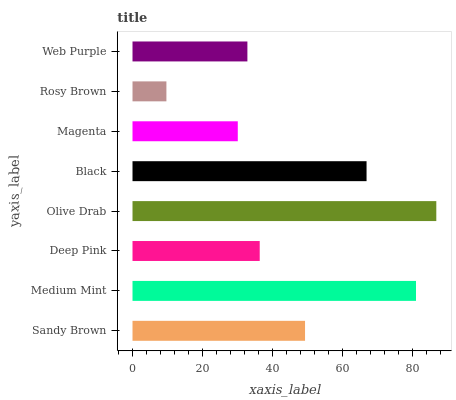Is Rosy Brown the minimum?
Answer yes or no. Yes. Is Olive Drab the maximum?
Answer yes or no. Yes. Is Medium Mint the minimum?
Answer yes or no. No. Is Medium Mint the maximum?
Answer yes or no. No. Is Medium Mint greater than Sandy Brown?
Answer yes or no. Yes. Is Sandy Brown less than Medium Mint?
Answer yes or no. Yes. Is Sandy Brown greater than Medium Mint?
Answer yes or no. No. Is Medium Mint less than Sandy Brown?
Answer yes or no. No. Is Sandy Brown the high median?
Answer yes or no. Yes. Is Deep Pink the low median?
Answer yes or no. Yes. Is Magenta the high median?
Answer yes or no. No. Is Rosy Brown the low median?
Answer yes or no. No. 